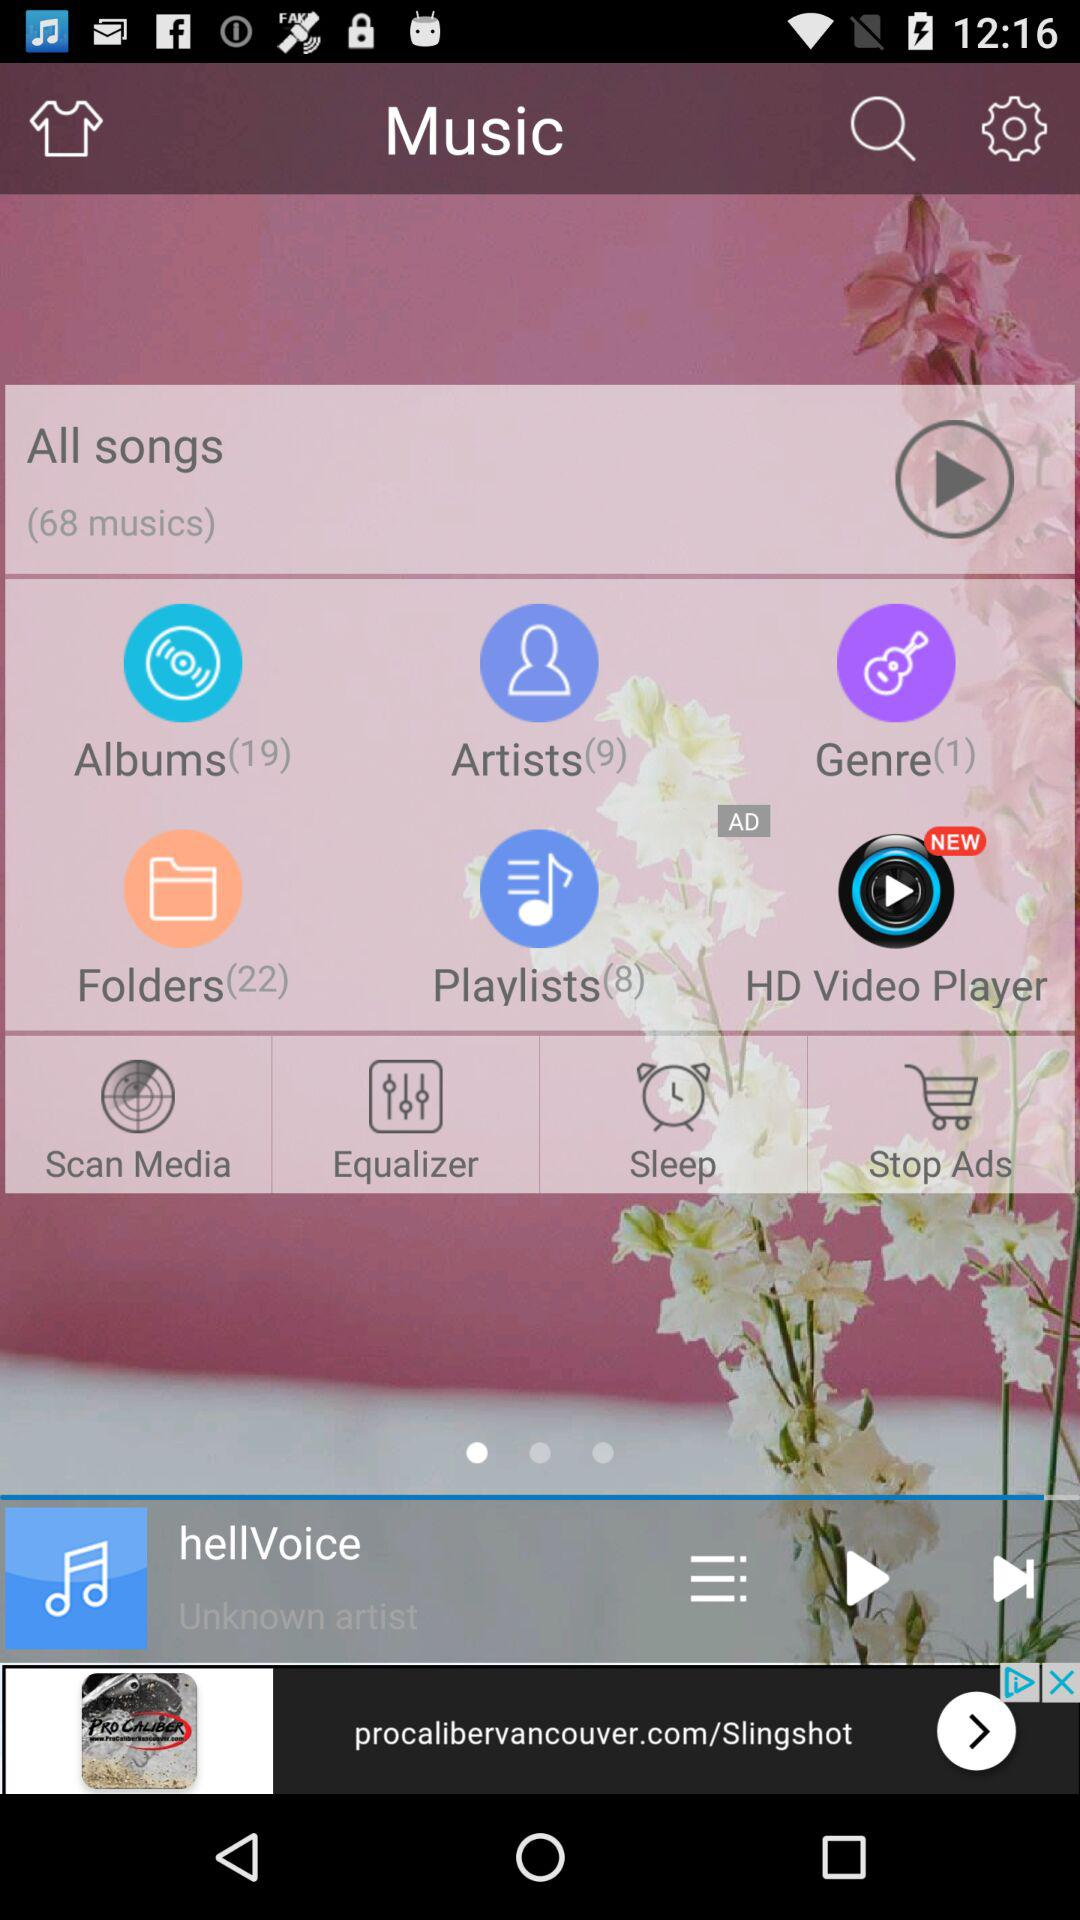What is the duration of "hellVoice"?
When the provided information is insufficient, respond with <no answer>. <no answer> 